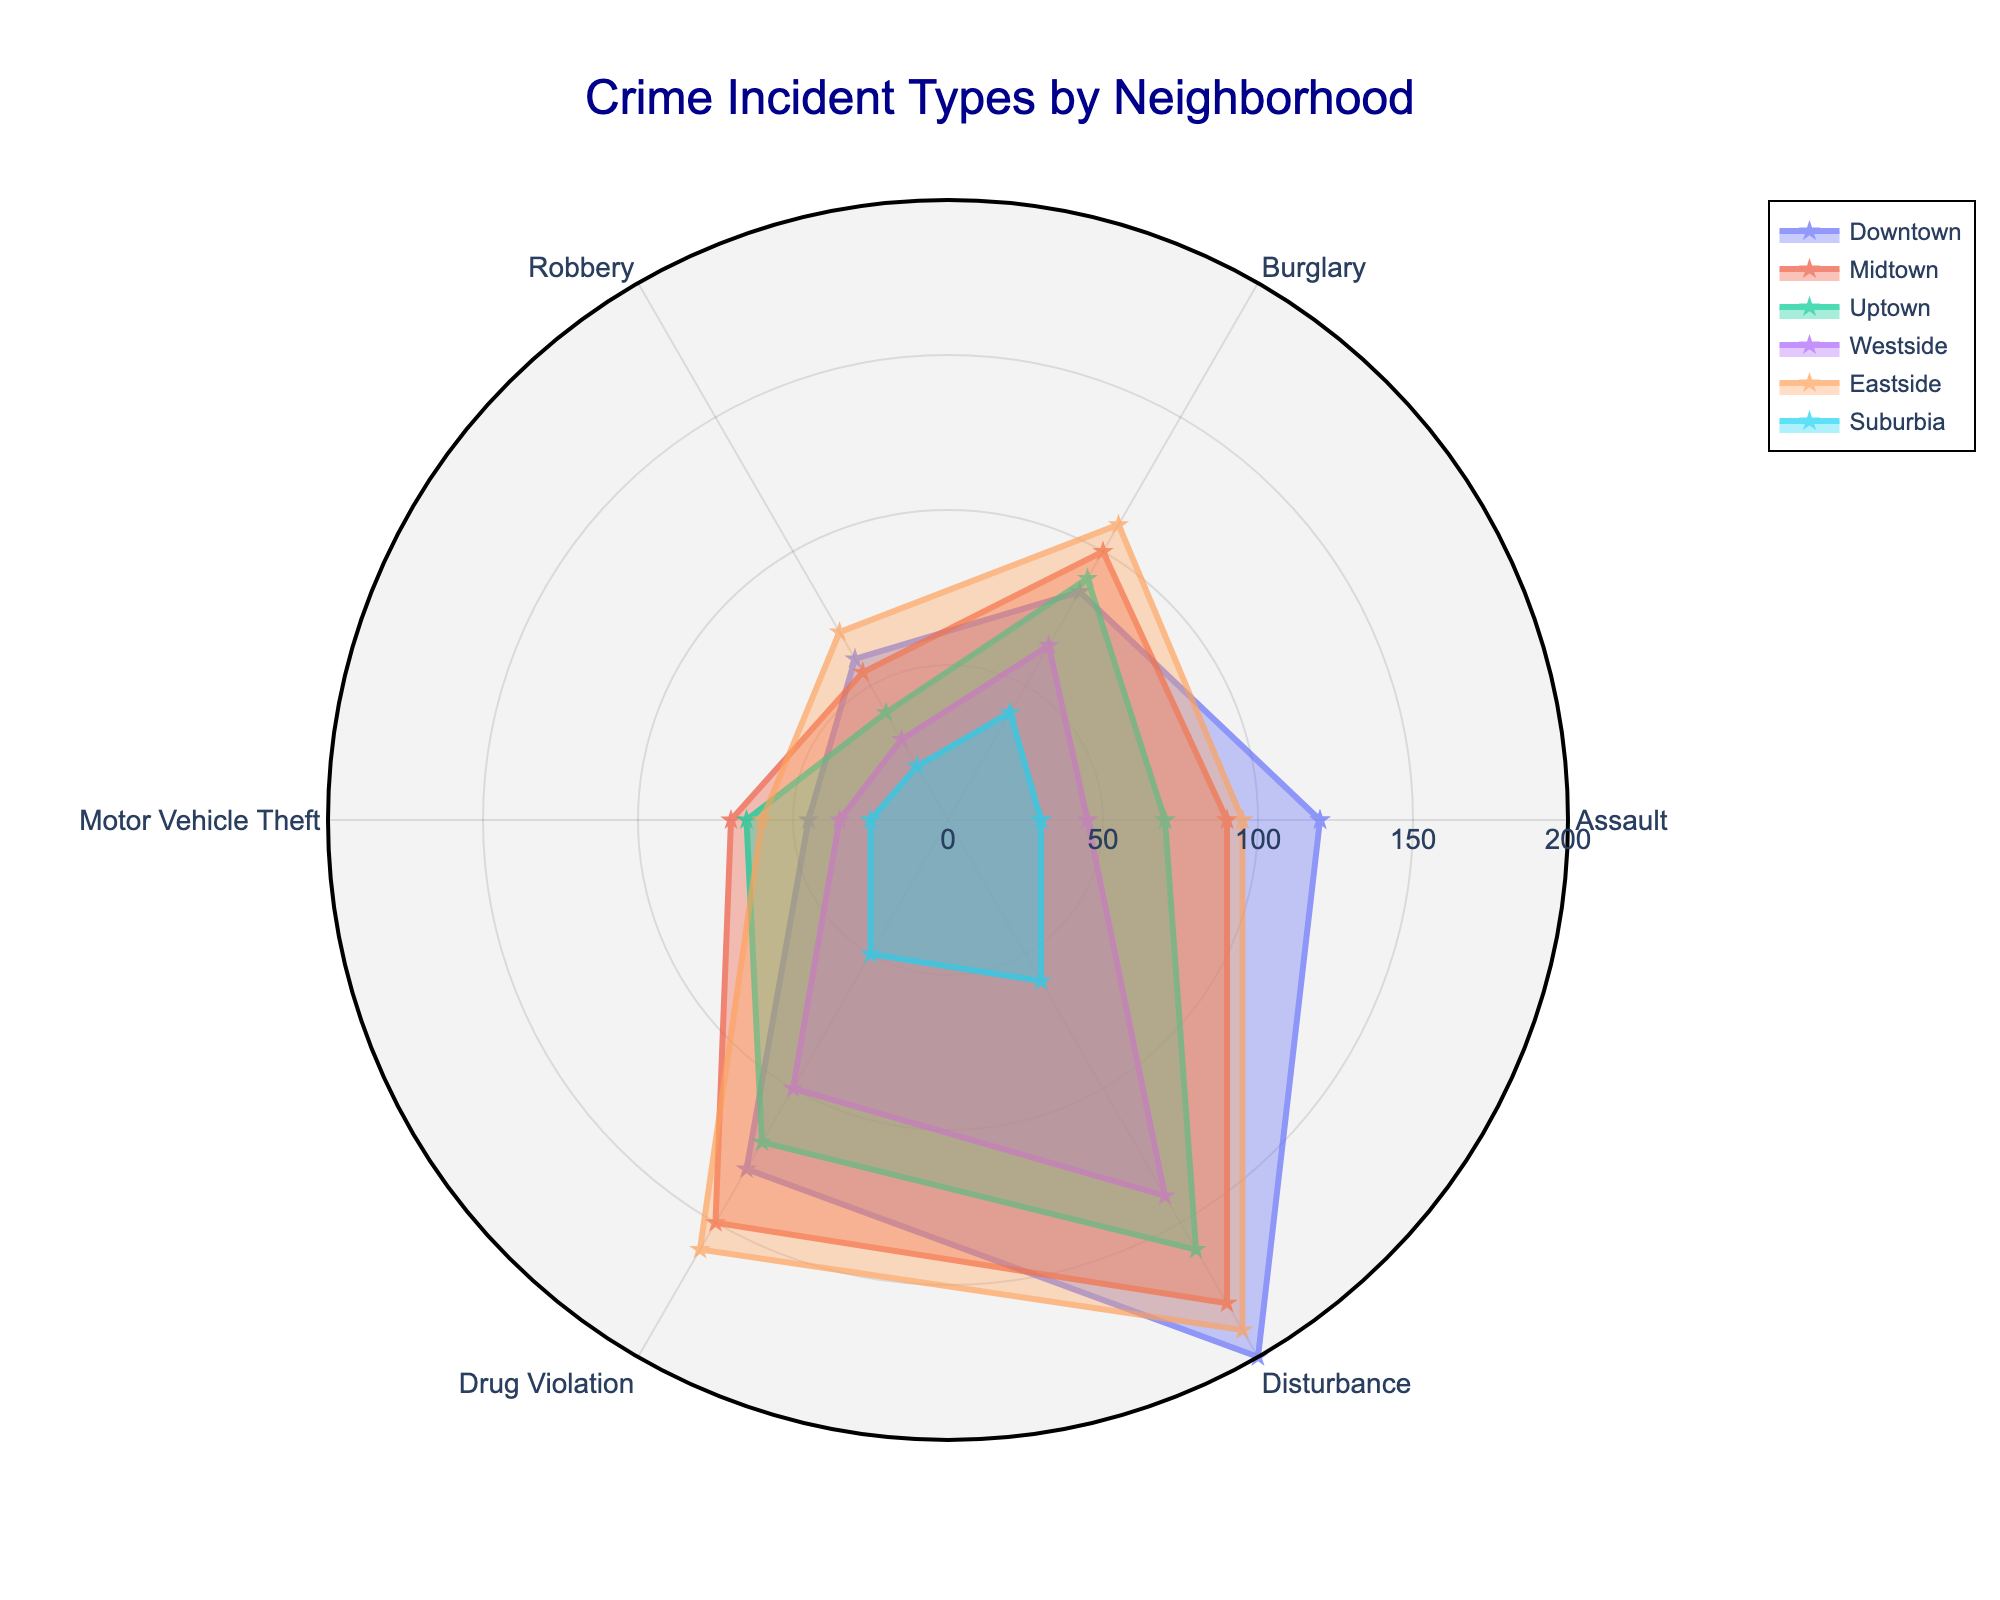What is the title of the figure? The title of the figure is usually positioned at the top and provides a brief description of the chart. In this case, it is written in a larger font size and states what the figure represents.
Answer: Crime Incident Types by Neighborhood Which neighborhood has the highest number of Drug Violations? By looking at the segment corresponding to 'Drug Violation' for all neighborhoods, we can identify which one has the highest radial distance. Eastside has the highest radial distance in the 'Drug Violation' segment.
Answer: Eastside How many crime types are compared for each neighborhood? Each sector in the polar chart represents a different crime type. By counting the distinct sectors, we can determine the number of crime types compared.
Answer: 6 What is the average number of Assault cases across all neighborhoods? Sum the number of Assault cases for all neighborhoods and then divide by the number of neighborhoods. The sum is 120 + 90 + 70 + 45 + 95 + 30 = 450, and there are 6 neighborhoods, so the average is 450/6.
Answer: 75 Which neighborhood has the lowest number of Motor Vehicle Theft incidents? By looking at the segment corresponding to 'Motor Vehicle Theft' for all neighborhoods, we can identify the one with the smallest radial distance. Suburbia has the smallest radial distance in the 'Motor Vehicle Theft' segment.
Answer: Suburbia How do the total incidents of Burglary in Downtown and Midtown compare? By looking at the 'Burglary' segment for both Downtown and Midtown, we can see their values and compare them. Downtown has 85 cases, and Midtown has 100 cases, so Midtown has more Burglary incidents than Downtown.
Answer: Midtown has more What's the overall highest number of incidents for any crime type in any neighborhood? Look for the maximum radial distance in the chart, which corresponds to the highest number of incidents for any crime type. The highest number for any crime type among the neighborhoods is 200 cases of Disturbance in Downtown.
Answer: 200 How does the total number of Disturbance incidents compare between the neighborhood with the highest and lowest disturbance records? Look at the 'Disturbance' segments and identify the highest and lowest values. Downtown has the highest with 200, and Suburbia has the lowest with 60. The difference is 200 - 60.
Answer: 140 Which crime type is more prevalent in Suburbia: Burglary or Motor Vehicle Theft? Compare the radial distances for 'Burglary' and 'Motor Vehicle Theft' in Suburbia. Burglary has 40 cases, and Motor Vehicle Theft has 25 cases, so Burglary is more prevalent.
Answer: Burglary Is Uptown or Westside experiencing more total crime incidents? Sum the incidents for each crime type in Uptown and Westside and compare the totals. Uptown's total is 70 + 90 + 40 + 65 + 120 + 160 = 545. Westside's total is 45 + 65 + 30 + 35 + 100 + 140 = 415. Therefore, Uptown has more total incidents.
Answer: Uptown 